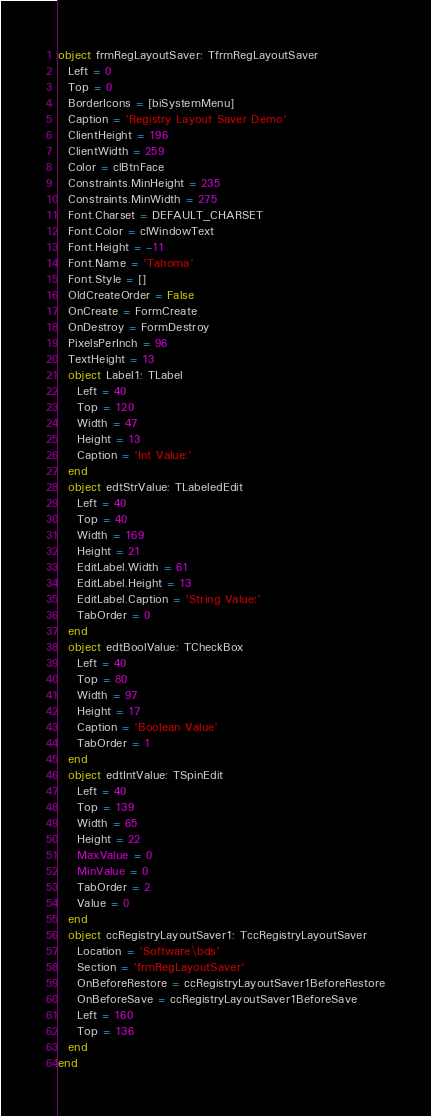<code> <loc_0><loc_0><loc_500><loc_500><_Pascal_>object frmRegLayoutSaver: TfrmRegLayoutSaver
  Left = 0
  Top = 0
  BorderIcons = [biSystemMenu]
  Caption = 'Registry Layout Saver Demo'
  ClientHeight = 196
  ClientWidth = 259
  Color = clBtnFace
  Constraints.MinHeight = 235
  Constraints.MinWidth = 275
  Font.Charset = DEFAULT_CHARSET
  Font.Color = clWindowText
  Font.Height = -11
  Font.Name = 'Tahoma'
  Font.Style = []
  OldCreateOrder = False
  OnCreate = FormCreate
  OnDestroy = FormDestroy
  PixelsPerInch = 96
  TextHeight = 13
  object Label1: TLabel
    Left = 40
    Top = 120
    Width = 47
    Height = 13
    Caption = 'Int Value:'
  end
  object edtStrValue: TLabeledEdit
    Left = 40
    Top = 40
    Width = 169
    Height = 21
    EditLabel.Width = 61
    EditLabel.Height = 13
    EditLabel.Caption = 'String Value:'
    TabOrder = 0
  end
  object edtBoolValue: TCheckBox
    Left = 40
    Top = 80
    Width = 97
    Height = 17
    Caption = 'Boolean Value'
    TabOrder = 1
  end
  object edtIntValue: TSpinEdit
    Left = 40
    Top = 139
    Width = 65
    Height = 22
    MaxValue = 0
    MinValue = 0
    TabOrder = 2
    Value = 0
  end
  object ccRegistryLayoutSaver1: TccRegistryLayoutSaver
    Location = 'Software\bds'
    Section = 'frmRegLayoutSaver'
    OnBeforeRestore = ccRegistryLayoutSaver1BeforeRestore
    OnBeforeSave = ccRegistryLayoutSaver1BeforeSave
    Left = 160
    Top = 136
  end
end
</code> 